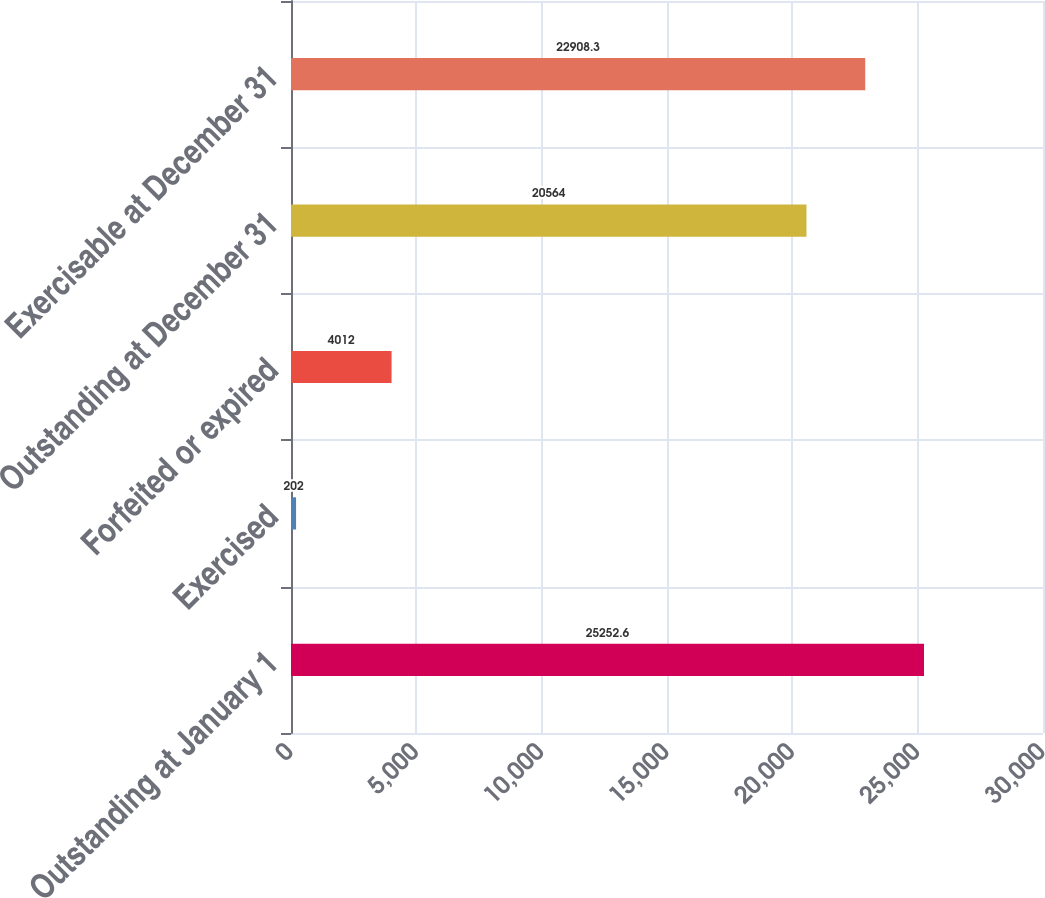<chart> <loc_0><loc_0><loc_500><loc_500><bar_chart><fcel>Outstanding at January 1<fcel>Exercised<fcel>Forfeited or expired<fcel>Outstanding at December 31<fcel>Exercisable at December 31<nl><fcel>25252.6<fcel>202<fcel>4012<fcel>20564<fcel>22908.3<nl></chart> 